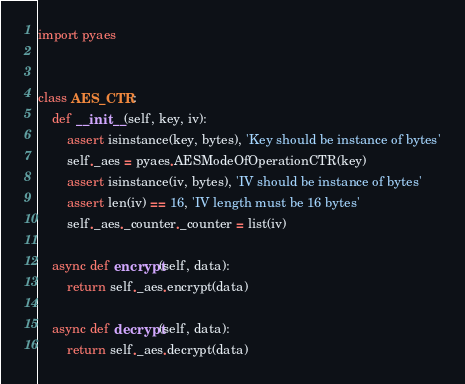<code> <loc_0><loc_0><loc_500><loc_500><_Python_>import pyaes


class AES_CTR:
    def __init__(self, key, iv):
        assert isinstance(key, bytes), 'Key should be instance of bytes'
        self._aes = pyaes.AESModeOfOperationCTR(key)
        assert isinstance(iv, bytes), 'IV should be instance of bytes'
        assert len(iv) == 16, 'IV length must be 16 bytes'
        self._aes._counter._counter = list(iv)

    async def encrypt(self, data):
        return self._aes.encrypt(data)

    async def decrypt(self, data):
        return self._aes.decrypt(data)
</code> 